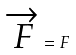Convert formula to latex. <formula><loc_0><loc_0><loc_500><loc_500>\overrightarrow { F } = F</formula> 